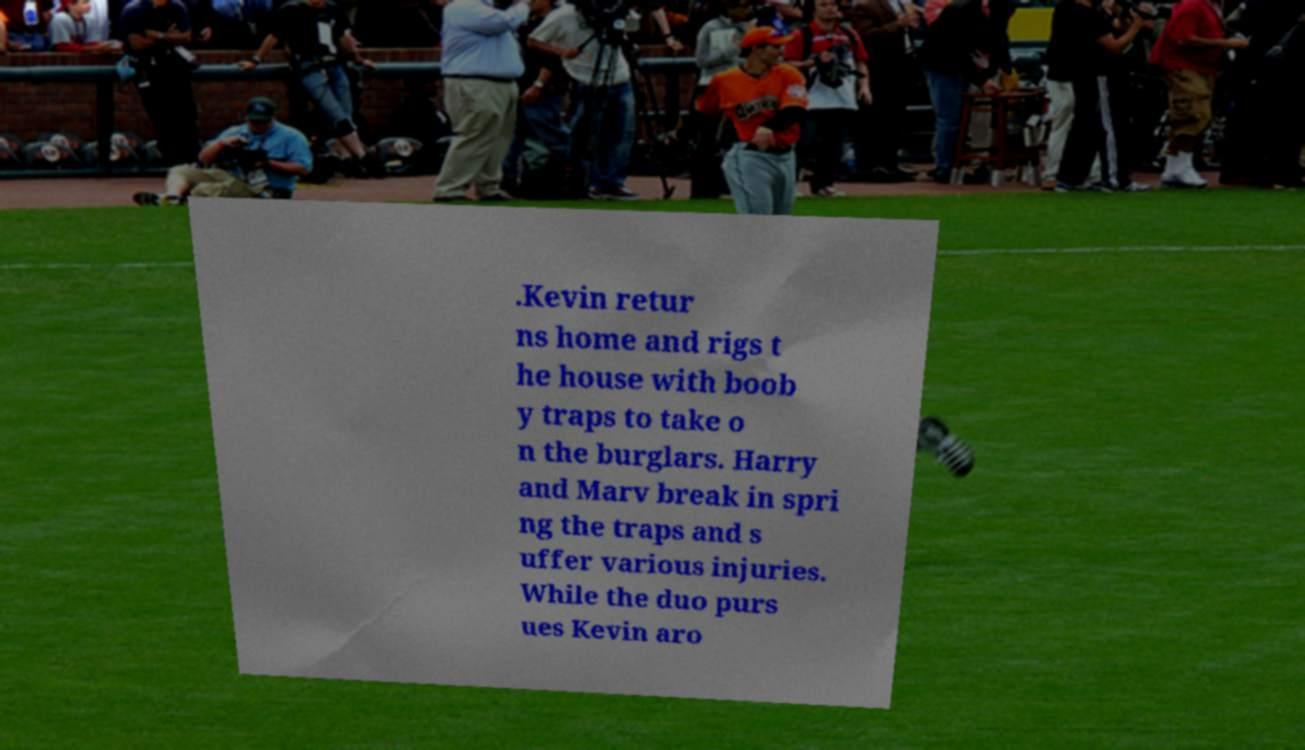For documentation purposes, I need the text within this image transcribed. Could you provide that? .Kevin retur ns home and rigs t he house with boob y traps to take o n the burglars. Harry and Marv break in spri ng the traps and s uffer various injuries. While the duo purs ues Kevin aro 